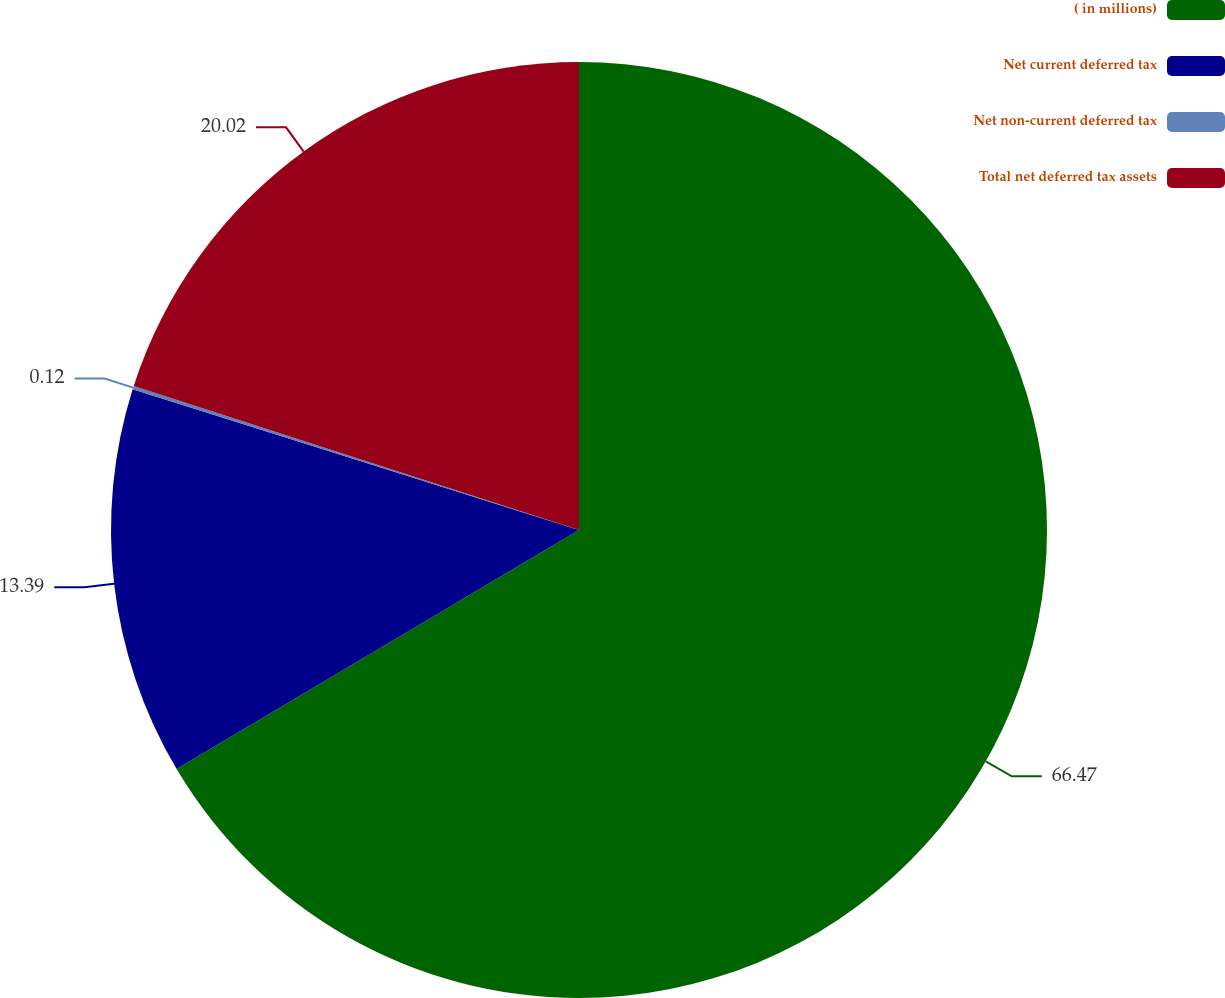Convert chart to OTSL. <chart><loc_0><loc_0><loc_500><loc_500><pie_chart><fcel>( in millions)<fcel>Net current deferred tax<fcel>Net non-current deferred tax<fcel>Total net deferred tax assets<nl><fcel>66.47%<fcel>13.39%<fcel>0.12%<fcel>20.02%<nl></chart> 